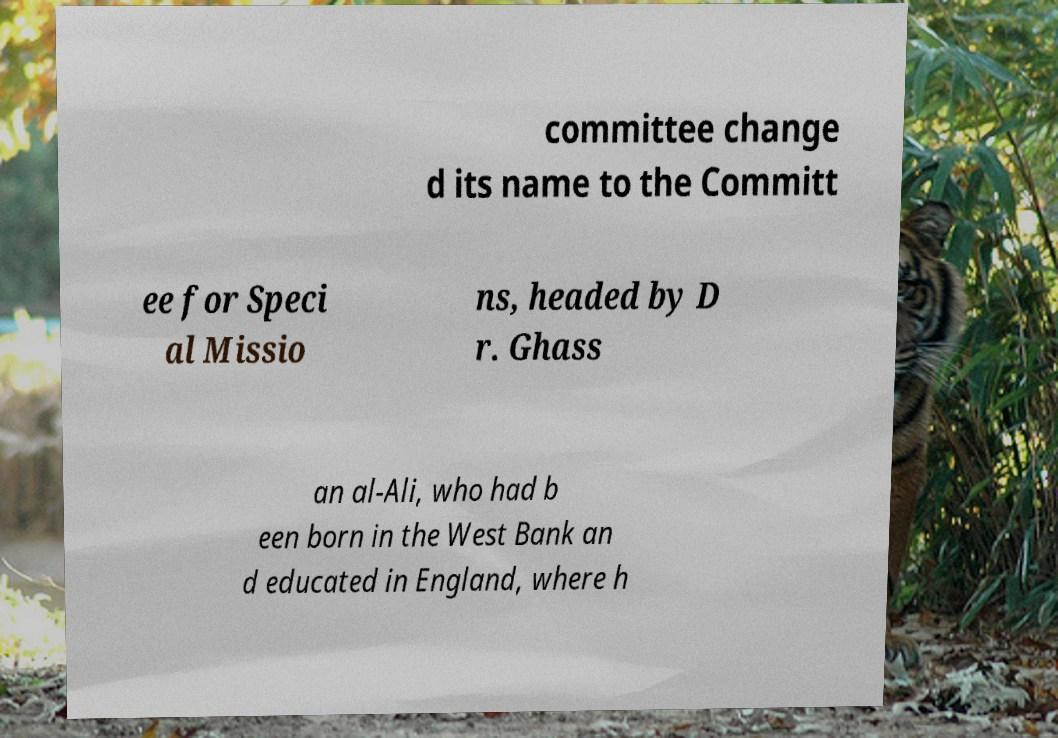What messages or text are displayed in this image? I need them in a readable, typed format. committee change d its name to the Committ ee for Speci al Missio ns, headed by D r. Ghass an al-Ali, who had b een born in the West Bank an d educated in England, where h 